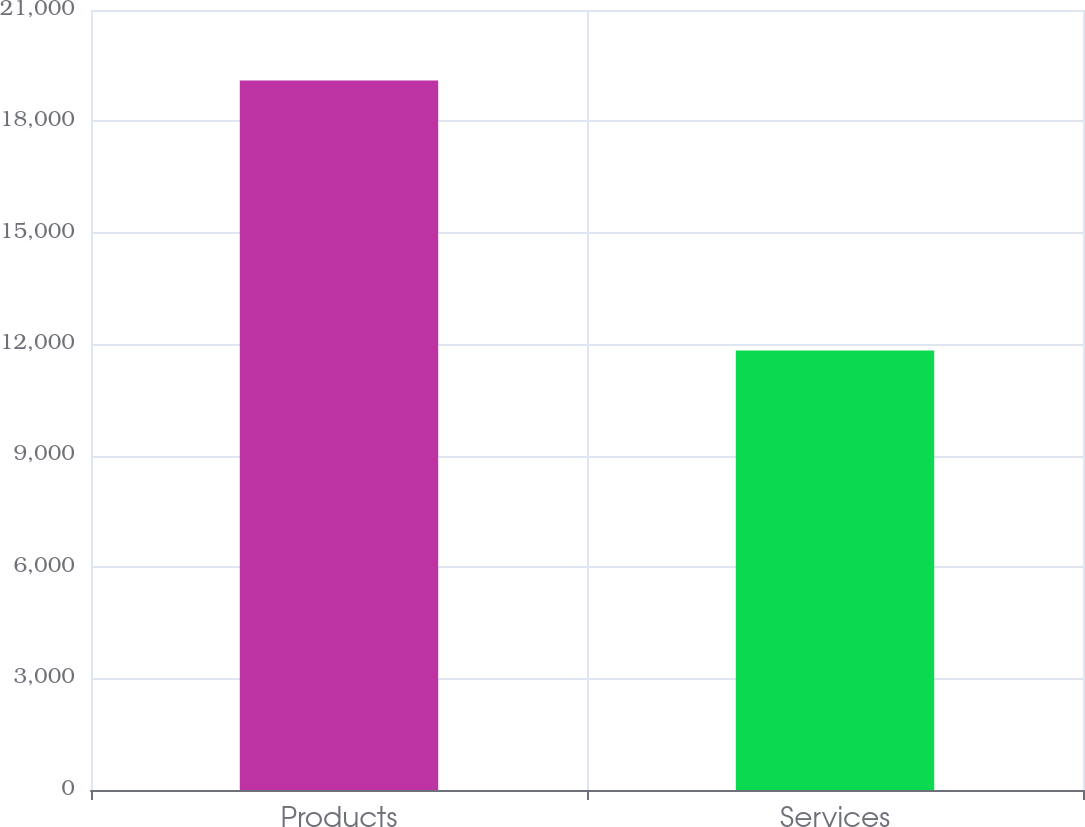Convert chart to OTSL. <chart><loc_0><loc_0><loc_500><loc_500><bar_chart><fcel>Products<fcel>Services<nl><fcel>19100<fcel>11830<nl></chart> 